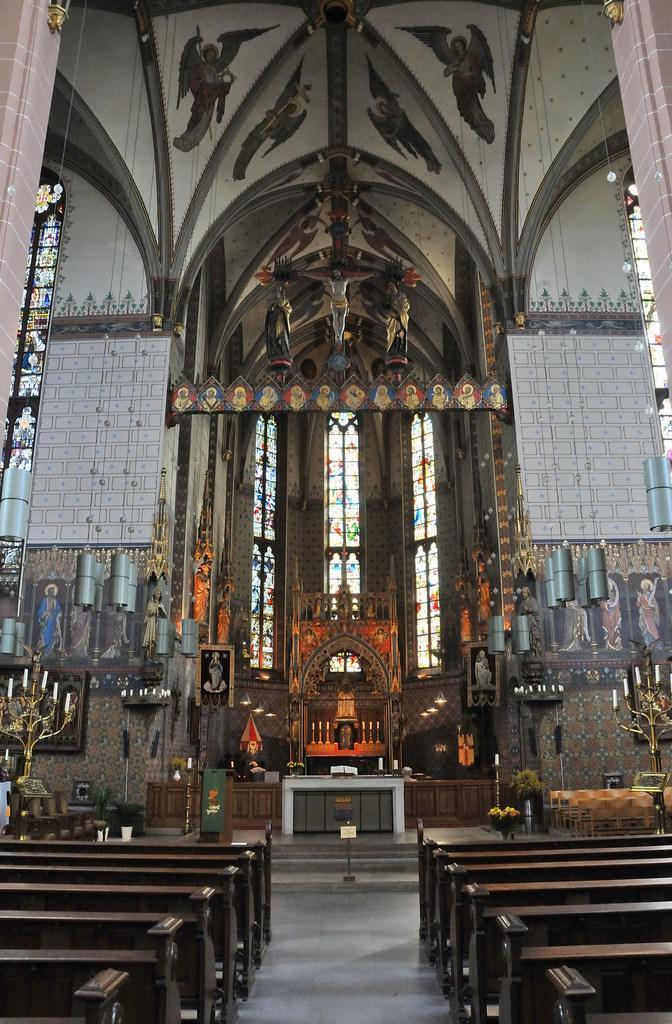Can you describe this image briefly? In this picture we can observe a church. There are brown color benches in this church. We can observe windows in the background. There is a wall here. We can observe an idol of Jesus here. 